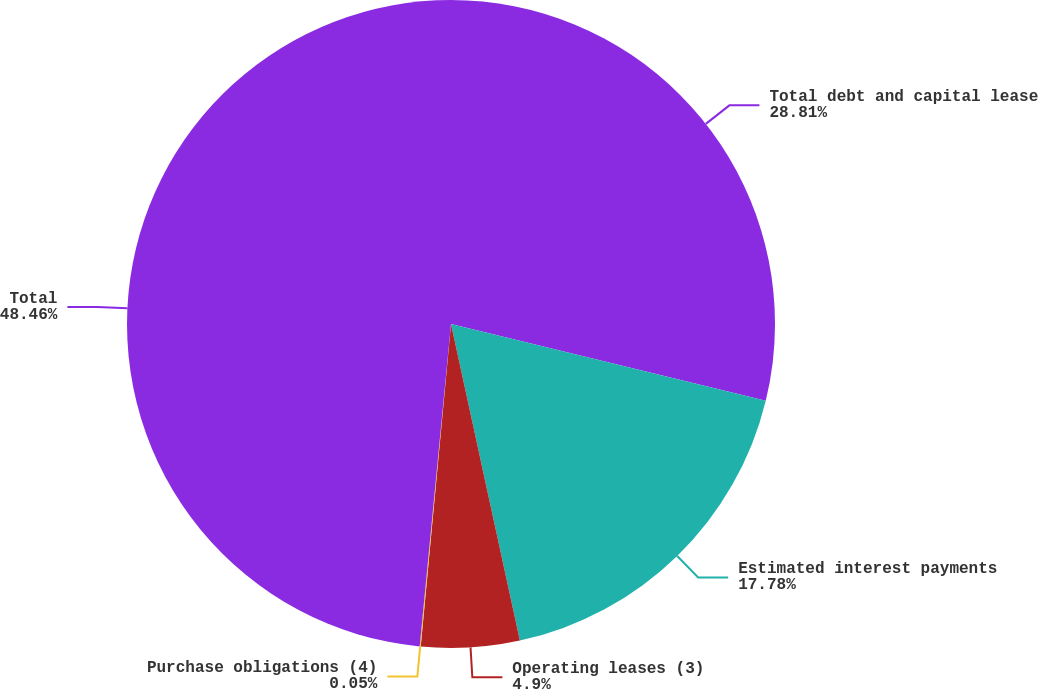<chart> <loc_0><loc_0><loc_500><loc_500><pie_chart><fcel>Total debt and capital lease<fcel>Estimated interest payments<fcel>Operating leases (3)<fcel>Purchase obligations (4)<fcel>Total<nl><fcel>28.81%<fcel>17.78%<fcel>4.9%<fcel>0.05%<fcel>48.46%<nl></chart> 